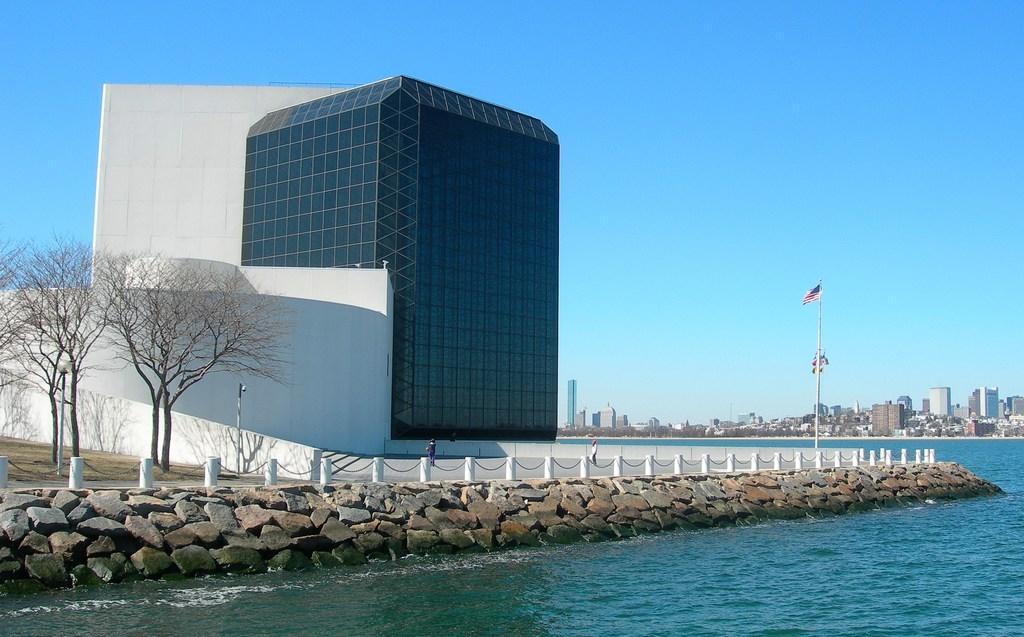Can you describe this image briefly? This is water. There are rocks, poles, flag, trees, and buildings. In the background there is sky. 